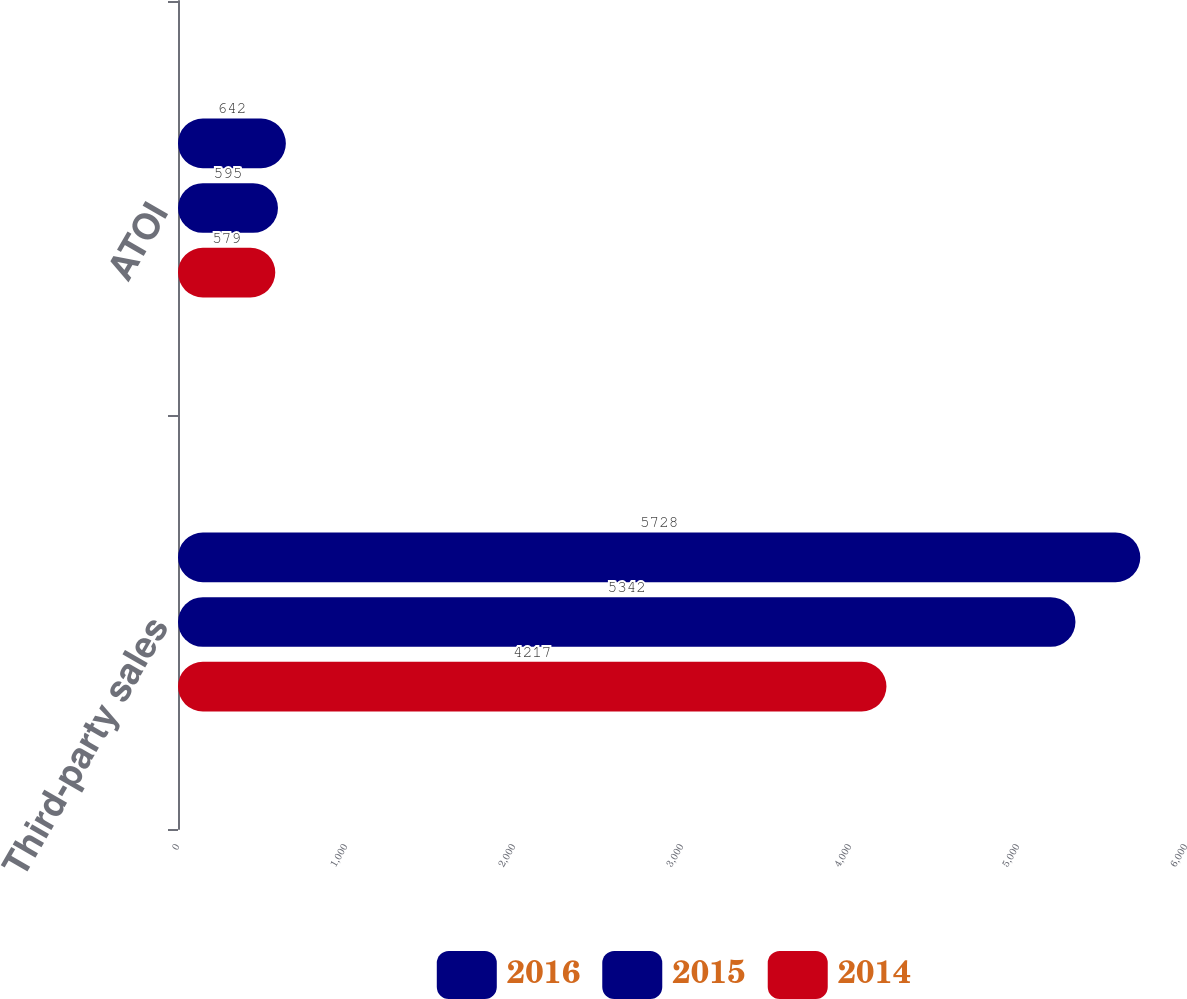Convert chart to OTSL. <chart><loc_0><loc_0><loc_500><loc_500><stacked_bar_chart><ecel><fcel>Third-party sales<fcel>ATOI<nl><fcel>2016<fcel>5728<fcel>642<nl><fcel>2015<fcel>5342<fcel>595<nl><fcel>2014<fcel>4217<fcel>579<nl></chart> 